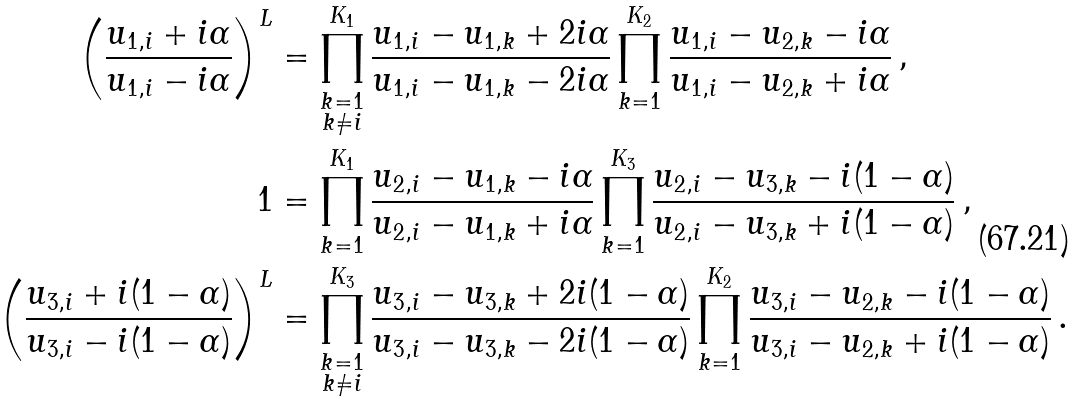<formula> <loc_0><loc_0><loc_500><loc_500>\left ( \frac { u _ { 1 , i } + i \alpha } { u _ { 1 , i } - i \alpha } \right ) ^ { L } & = \prod _ { \substack { k = 1 \\ k \neq i } } ^ { K _ { 1 } } \frac { u _ { 1 , i } - u _ { 1 , k } + 2 i \alpha } { u _ { 1 , i } - u _ { 1 , k } - 2 i \alpha } \prod _ { k = 1 } ^ { K _ { 2 } } \frac { u _ { 1 , i } - u _ { 2 , k } - i \alpha } { u _ { 1 , i } - u _ { 2 , k } + i \alpha } \, , \\ 1 & = \prod _ { k = 1 } ^ { K _ { 1 } } \frac { u _ { 2 , i } - u _ { 1 , k } - i \alpha } { u _ { 2 , i } - u _ { 1 , k } + i \alpha } \prod _ { k = 1 } ^ { K _ { 3 } } \frac { u _ { 2 , i } - u _ { 3 , k } - i ( 1 - \alpha ) } { u _ { 2 , i } - u _ { 3 , k } + i ( 1 - \alpha ) } \, , \\ \left ( \frac { u _ { 3 , i } + i ( 1 - \alpha ) } { u _ { 3 , i } - i ( 1 - \alpha ) } \right ) ^ { L } & = \prod _ { \substack { k = 1 \\ k \neq i } } ^ { K _ { 3 } } \frac { u _ { 3 , i } - u _ { 3 , k } + 2 i ( 1 - \alpha ) } { u _ { 3 , i } - u _ { 3 , k } - 2 i ( 1 - \alpha ) } \prod _ { k = 1 } ^ { K _ { 2 } } \frac { u _ { 3 , i } - u _ { 2 , k } - i ( 1 - \alpha ) } { u _ { 3 , i } - u _ { 2 , k } + i ( 1 - \alpha ) } \, .</formula> 